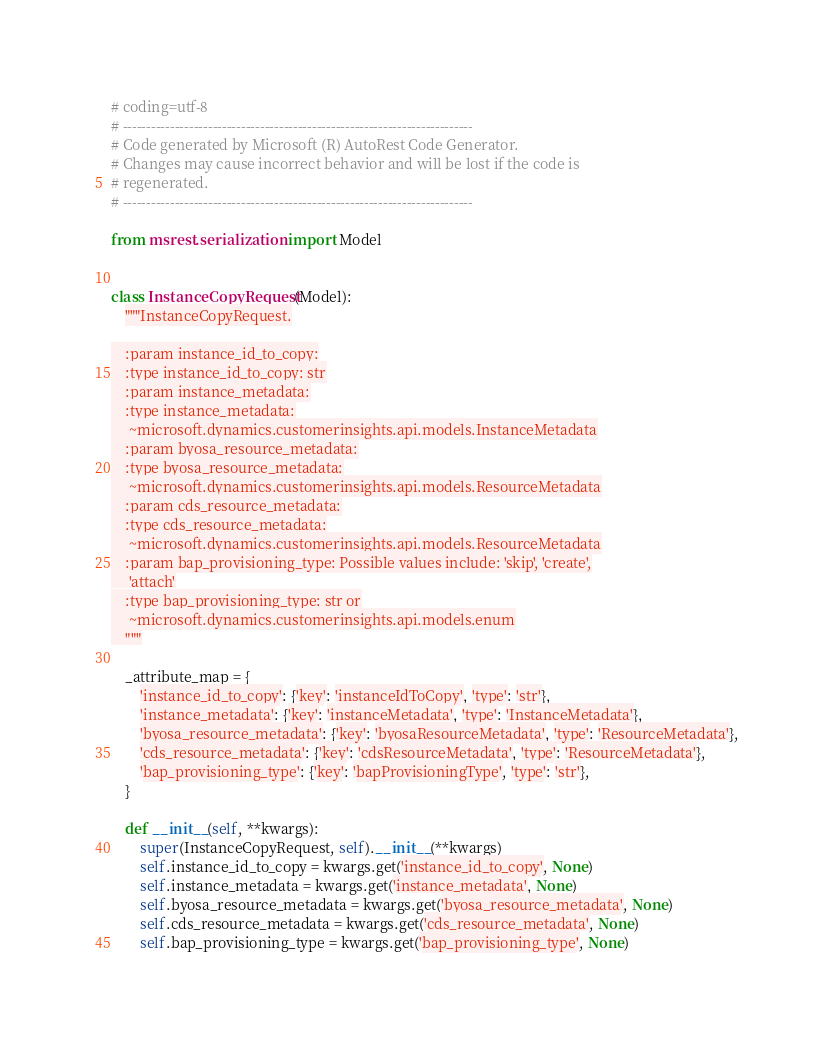Convert code to text. <code><loc_0><loc_0><loc_500><loc_500><_Python_># coding=utf-8
# --------------------------------------------------------------------------
# Code generated by Microsoft (R) AutoRest Code Generator.
# Changes may cause incorrect behavior and will be lost if the code is
# regenerated.
# --------------------------------------------------------------------------

from msrest.serialization import Model


class InstanceCopyRequest(Model):
    """InstanceCopyRequest.

    :param instance_id_to_copy:
    :type instance_id_to_copy: str
    :param instance_metadata:
    :type instance_metadata:
     ~microsoft.dynamics.customerinsights.api.models.InstanceMetadata
    :param byosa_resource_metadata:
    :type byosa_resource_metadata:
     ~microsoft.dynamics.customerinsights.api.models.ResourceMetadata
    :param cds_resource_metadata:
    :type cds_resource_metadata:
     ~microsoft.dynamics.customerinsights.api.models.ResourceMetadata
    :param bap_provisioning_type: Possible values include: 'skip', 'create',
     'attach'
    :type bap_provisioning_type: str or
     ~microsoft.dynamics.customerinsights.api.models.enum
    """

    _attribute_map = {
        'instance_id_to_copy': {'key': 'instanceIdToCopy', 'type': 'str'},
        'instance_metadata': {'key': 'instanceMetadata', 'type': 'InstanceMetadata'},
        'byosa_resource_metadata': {'key': 'byosaResourceMetadata', 'type': 'ResourceMetadata'},
        'cds_resource_metadata': {'key': 'cdsResourceMetadata', 'type': 'ResourceMetadata'},
        'bap_provisioning_type': {'key': 'bapProvisioningType', 'type': 'str'},
    }

    def __init__(self, **kwargs):
        super(InstanceCopyRequest, self).__init__(**kwargs)
        self.instance_id_to_copy = kwargs.get('instance_id_to_copy', None)
        self.instance_metadata = kwargs.get('instance_metadata', None)
        self.byosa_resource_metadata = kwargs.get('byosa_resource_metadata', None)
        self.cds_resource_metadata = kwargs.get('cds_resource_metadata', None)
        self.bap_provisioning_type = kwargs.get('bap_provisioning_type', None)
</code> 